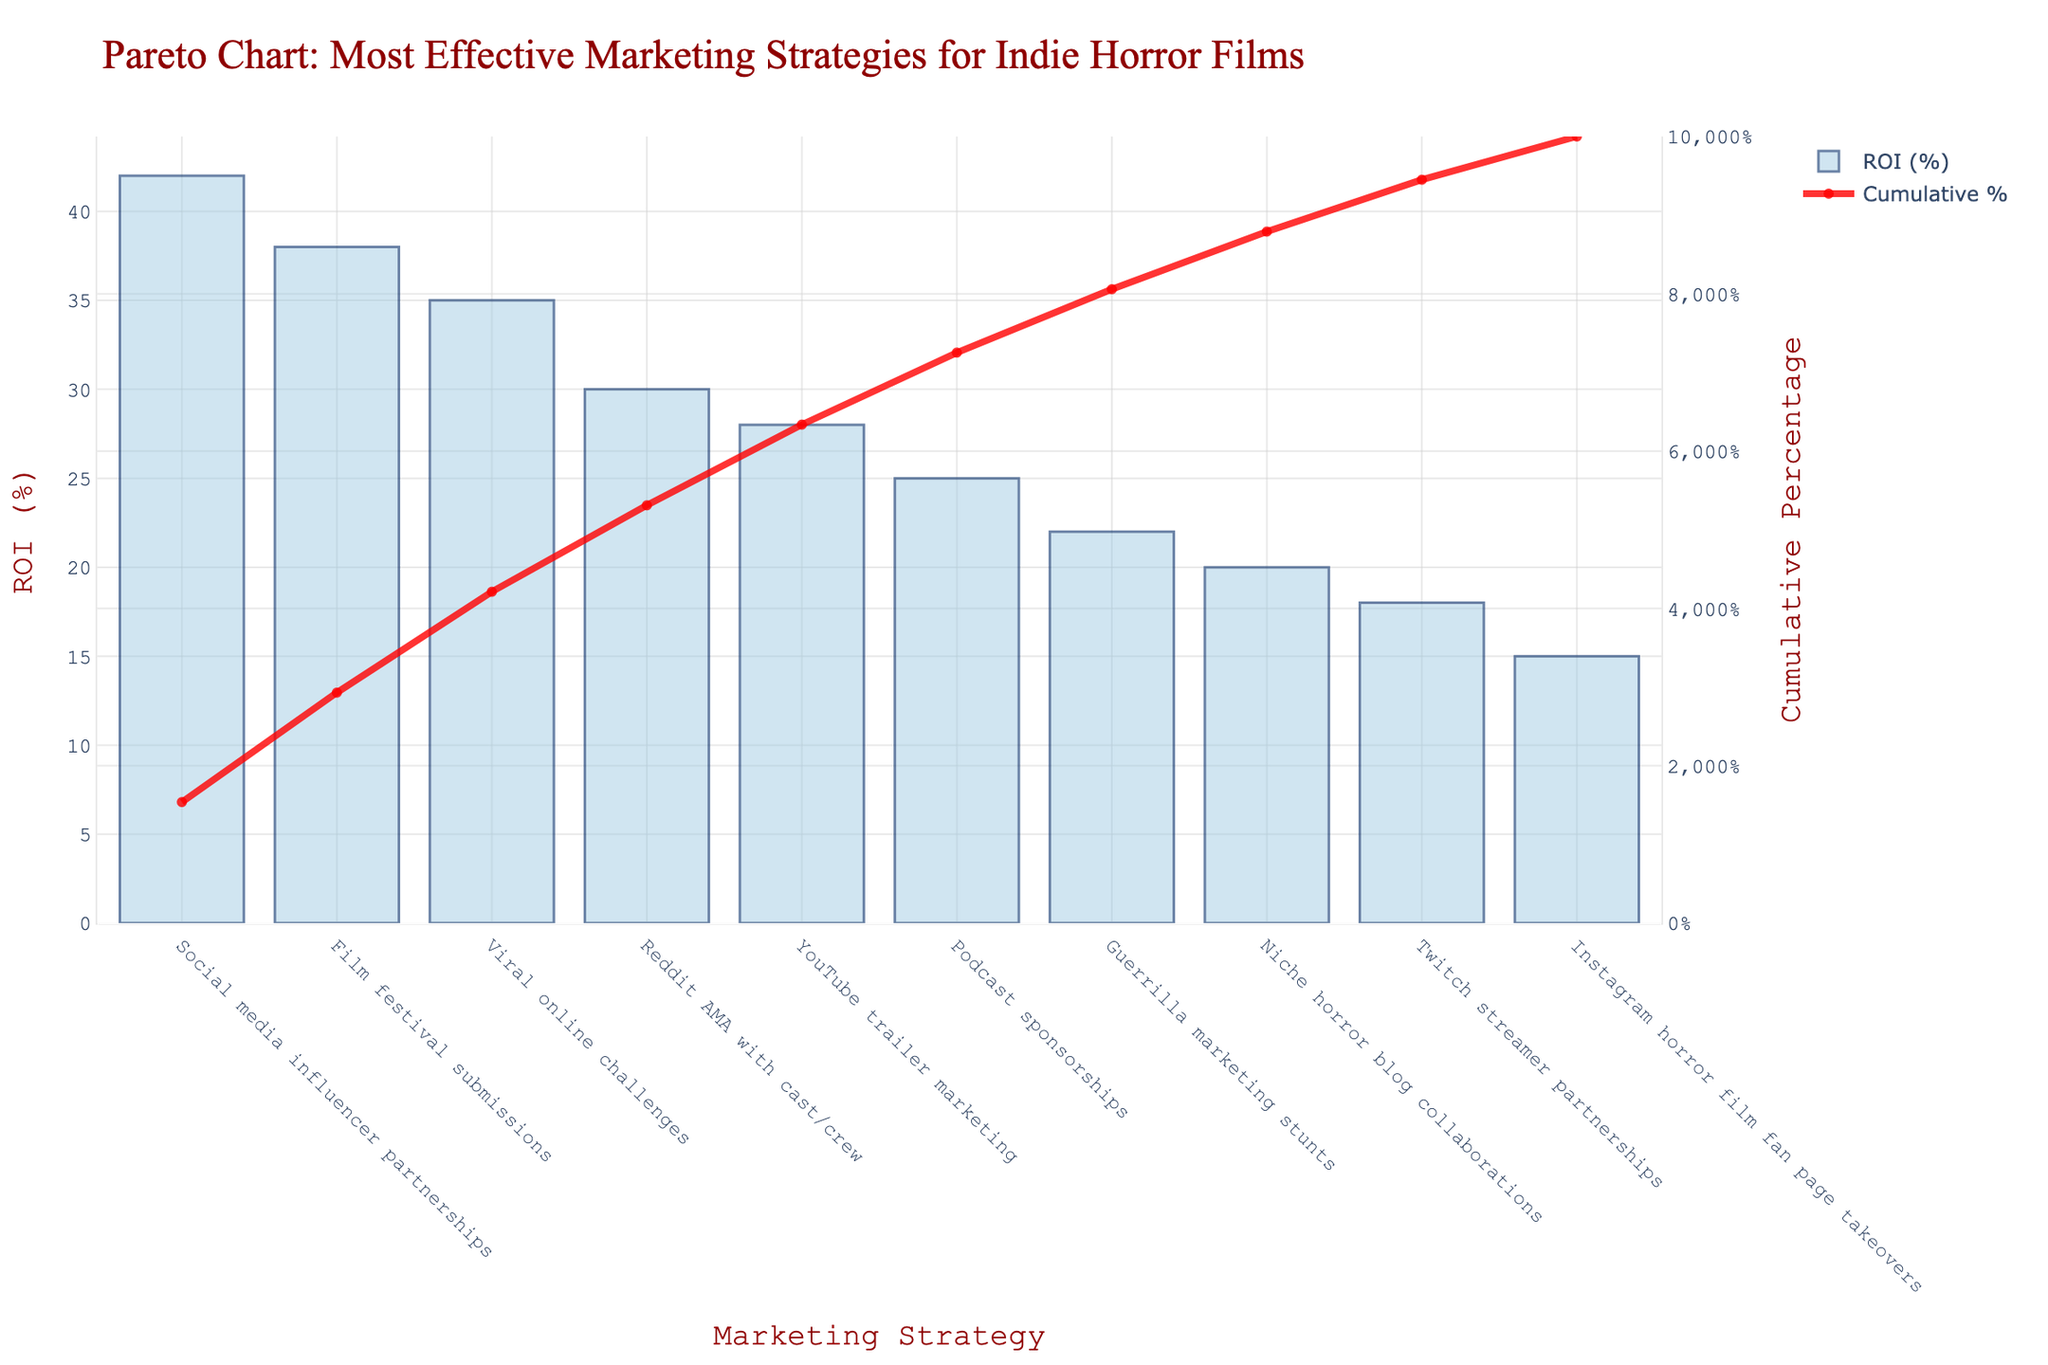What is the title of the chart? The title of the chart is located at the top of the figure. It is written in larger, bold font.
Answer: Pareto Chart: Most Effective Marketing Strategies for Indie Horror Films Which marketing strategy has the highest ROI? The strategy with the highest ROI is represented by the tallest bar on the chart, which is located on the leftmost side of the x-axis.
Answer: Social media influencer partnerships What is the cumulative percentage when the ROI of YouTube trailer marketing is included? Find the position of "YouTube trailer marketing" on the x-axis, then look at the secondary y-axis value for the cumulative percentage corresponding to that strategy.
Answer: 86% How many marketing strategies have an ROI above 30%? Count the bars that have a height greater than the 30% mark on the primary y-axis.
Answer: 4 What is the difference in ROI between Film festival submissions and Instagram horror film fan page takeovers? Subtract the ROI of Instagram horror film fan page takeovers from the ROI of Film festival submissions.
Answer: 23% Which marketing strategy is the least effective based on ROI? The least effective strategy is represented by the shortest bar on the chart, which is located on the rightmost side of the x-axis.
Answer: Instagram horror film fan page takeovers What is the cumulative percentage of the top 3 marketing strategies? Add the cumulative percentages for the top 3 strategies visible on the secondary y-axis at the position aligned with the third bar.
Answer: 115% How does the ROI of Podcast sponsorships compare to Guerrilla marketing stunts? Look at the height of the bars for both strategies and see which one is taller.
Answer: Podcast sponsorships have a higher ROI By how much does the cumulative percentage increase when moving from Reddit AMA with cast/crew to YouTube trailer marketing? Find the cumulative percentages for both strategies and calculate the difference between them.
Answer: 28% What percentage of the total ROI is covered by the first 5 strategies? Check the cumulative percentage value at the position aligning with the fifth bar and read it directly.
Answer: 173% 